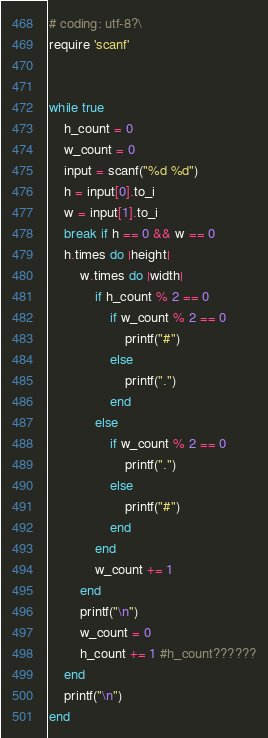Convert code to text. <code><loc_0><loc_0><loc_500><loc_500><_Ruby_># coding: utf-8?\
require 'scanf'


while true
	h_count = 0
	w_count = 0
	input = scanf("%d %d")
	h = input[0].to_i 
	w = input[1].to_i 
	break if h == 0 && w == 0
	h.times do |height|
		w.times do |width|
			if h_count % 2 == 0
				if w_count % 2 == 0
					printf("#")
				else
					printf(".")
				end
			else
				if w_count % 2 == 0
					printf(".")
				else
					printf("#")
				end
			end
			w_count += 1
		end
		printf("\n")
		w_count = 0
		h_count += 1 #h_count??????
	end
	printf("\n")
end</code> 